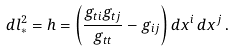<formula> <loc_0><loc_0><loc_500><loc_500>d l _ { * } ^ { 2 } = h = \left ( \frac { g _ { t i } g _ { t j } } { g _ { t t } } - g _ { i j } \right ) d x ^ { i } \, d x ^ { j } \, .</formula> 